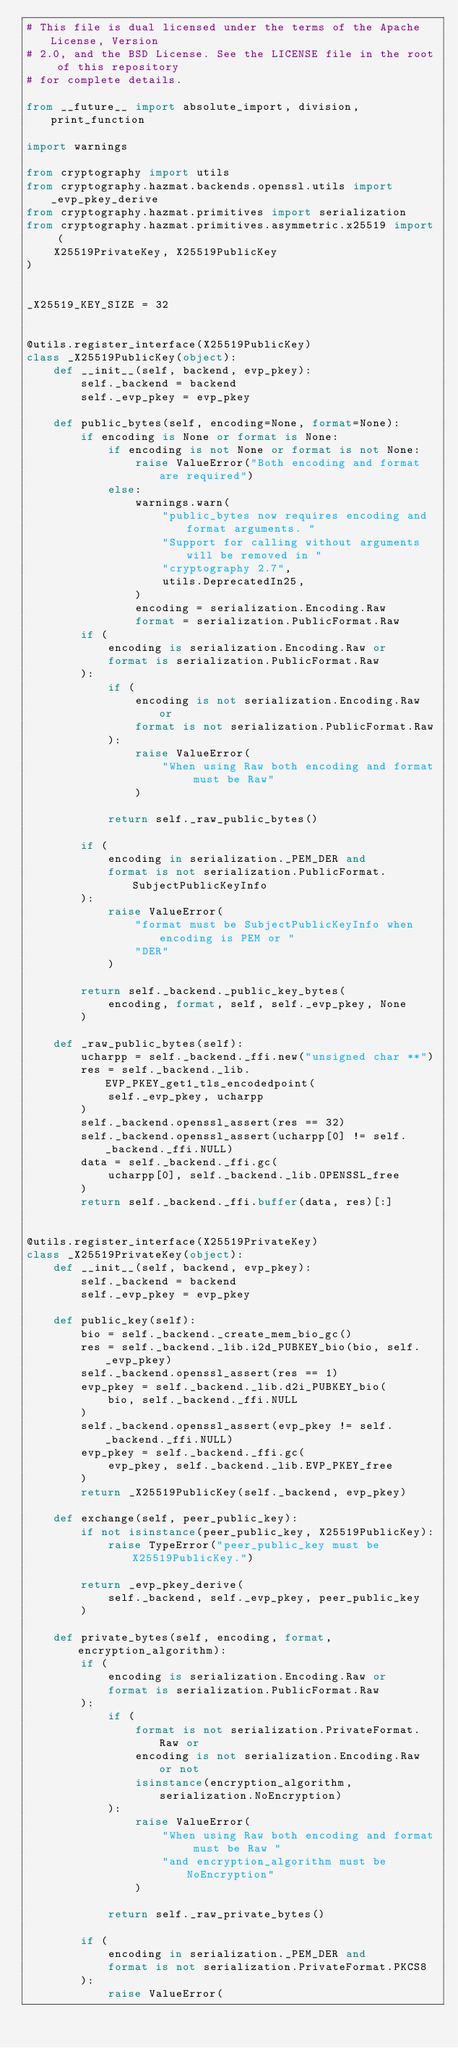Convert code to text. <code><loc_0><loc_0><loc_500><loc_500><_Python_># This file is dual licensed under the terms of the Apache License, Version
# 2.0, and the BSD License. See the LICENSE file in the root of this repository
# for complete details.

from __future__ import absolute_import, division, print_function

import warnings

from cryptography import utils
from cryptography.hazmat.backends.openssl.utils import _evp_pkey_derive
from cryptography.hazmat.primitives import serialization
from cryptography.hazmat.primitives.asymmetric.x25519 import (
    X25519PrivateKey, X25519PublicKey
)


_X25519_KEY_SIZE = 32


@utils.register_interface(X25519PublicKey)
class _X25519PublicKey(object):
    def __init__(self, backend, evp_pkey):
        self._backend = backend
        self._evp_pkey = evp_pkey

    def public_bytes(self, encoding=None, format=None):
        if encoding is None or format is None:
            if encoding is not None or format is not None:
                raise ValueError("Both encoding and format are required")
            else:
                warnings.warn(
                    "public_bytes now requires encoding and format arguments. "
                    "Support for calling without arguments will be removed in "
                    "cryptography 2.7",
                    utils.DeprecatedIn25,
                )
                encoding = serialization.Encoding.Raw
                format = serialization.PublicFormat.Raw
        if (
            encoding is serialization.Encoding.Raw or
            format is serialization.PublicFormat.Raw
        ):
            if (
                encoding is not serialization.Encoding.Raw or
                format is not serialization.PublicFormat.Raw
            ):
                raise ValueError(
                    "When using Raw both encoding and format must be Raw"
                )

            return self._raw_public_bytes()

        if (
            encoding in serialization._PEM_DER and
            format is not serialization.PublicFormat.SubjectPublicKeyInfo
        ):
            raise ValueError(
                "format must be SubjectPublicKeyInfo when encoding is PEM or "
                "DER"
            )

        return self._backend._public_key_bytes(
            encoding, format, self, self._evp_pkey, None
        )

    def _raw_public_bytes(self):
        ucharpp = self._backend._ffi.new("unsigned char **")
        res = self._backend._lib.EVP_PKEY_get1_tls_encodedpoint(
            self._evp_pkey, ucharpp
        )
        self._backend.openssl_assert(res == 32)
        self._backend.openssl_assert(ucharpp[0] != self._backend._ffi.NULL)
        data = self._backend._ffi.gc(
            ucharpp[0], self._backend._lib.OPENSSL_free
        )
        return self._backend._ffi.buffer(data, res)[:]


@utils.register_interface(X25519PrivateKey)
class _X25519PrivateKey(object):
    def __init__(self, backend, evp_pkey):
        self._backend = backend
        self._evp_pkey = evp_pkey

    def public_key(self):
        bio = self._backend._create_mem_bio_gc()
        res = self._backend._lib.i2d_PUBKEY_bio(bio, self._evp_pkey)
        self._backend.openssl_assert(res == 1)
        evp_pkey = self._backend._lib.d2i_PUBKEY_bio(
            bio, self._backend._ffi.NULL
        )
        self._backend.openssl_assert(evp_pkey != self._backend._ffi.NULL)
        evp_pkey = self._backend._ffi.gc(
            evp_pkey, self._backend._lib.EVP_PKEY_free
        )
        return _X25519PublicKey(self._backend, evp_pkey)

    def exchange(self, peer_public_key):
        if not isinstance(peer_public_key, X25519PublicKey):
            raise TypeError("peer_public_key must be X25519PublicKey.")

        return _evp_pkey_derive(
            self._backend, self._evp_pkey, peer_public_key
        )

    def private_bytes(self, encoding, format, encryption_algorithm):
        if (
            encoding is serialization.Encoding.Raw or
            format is serialization.PublicFormat.Raw
        ):
            if (
                format is not serialization.PrivateFormat.Raw or
                encoding is not serialization.Encoding.Raw or not
                isinstance(encryption_algorithm, serialization.NoEncryption)
            ):
                raise ValueError(
                    "When using Raw both encoding and format must be Raw "
                    "and encryption_algorithm must be NoEncryption"
                )

            return self._raw_private_bytes()

        if (
            encoding in serialization._PEM_DER and
            format is not serialization.PrivateFormat.PKCS8
        ):
            raise ValueError(</code> 